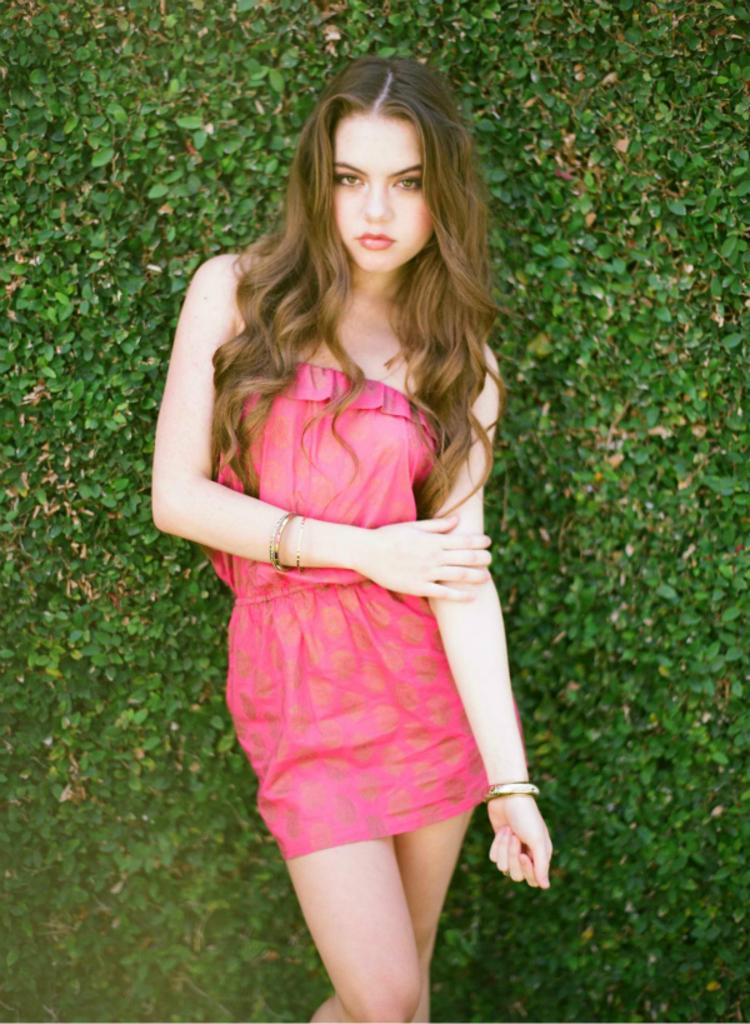Who is present in the image? There is a woman standing in the image. What can be seen in the background of the image? There are trees in the background of the image. What is the color of the trees in the image? The trees are green in color. What type of wire is being used to play the drum in the image? There is no wire or drum present in the image; it only features a woman standing in front of green trees. 